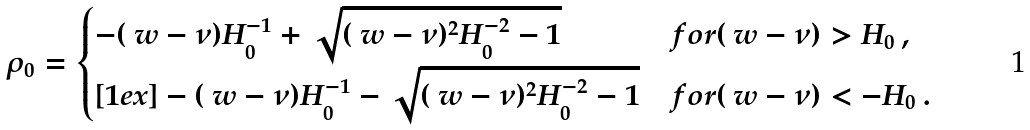<formula> <loc_0><loc_0><loc_500><loc_500>\rho _ { 0 } = \begin{cases} - ( \ w - \nu ) H _ { 0 } ^ { - 1 } + \sqrt { ( \ w - \nu ) ^ { 2 } H _ { 0 } ^ { - 2 } - 1 } & f o r ( \ w - \nu ) > H _ { 0 } \, , \\ [ 1 e x ] - ( \ w - \nu ) H _ { 0 } ^ { - 1 } - \sqrt { ( \ w - \nu ) ^ { 2 } H _ { 0 } ^ { - 2 } - 1 } & f o r ( \ w - \nu ) < - H _ { 0 } \, . \end{cases}</formula> 